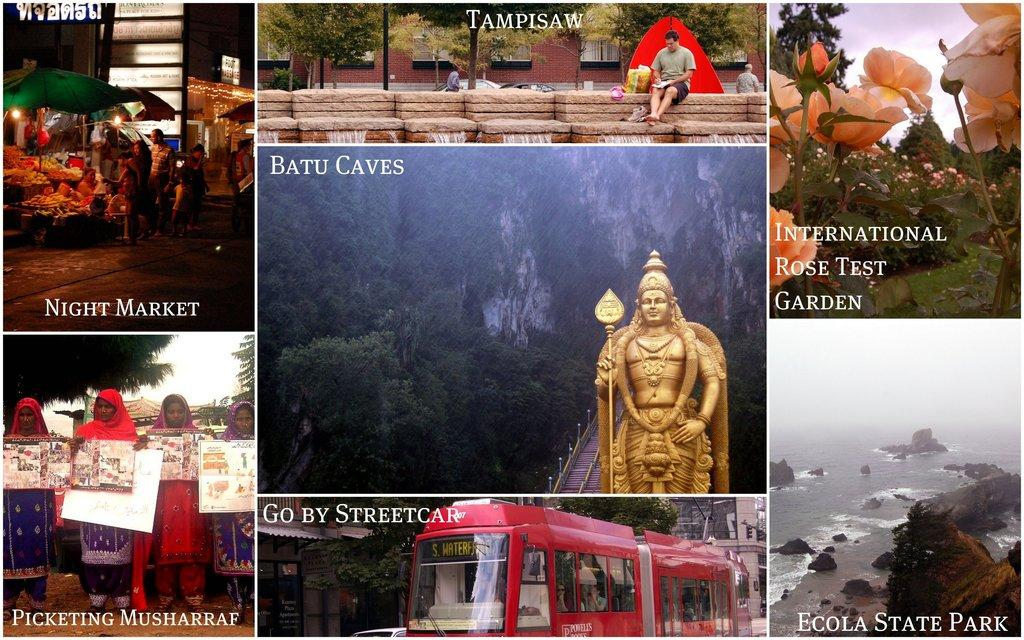<image>
Present a compact description of the photo's key features. Tourist pictures including ones of the Batu Caves. 